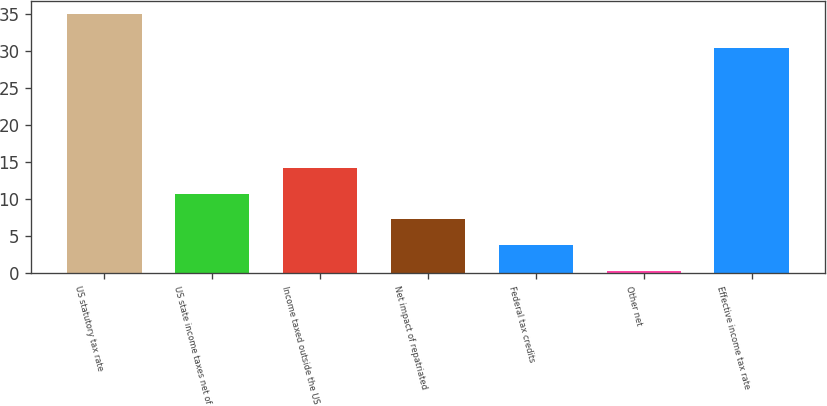<chart> <loc_0><loc_0><loc_500><loc_500><bar_chart><fcel>US statutory tax rate<fcel>US state income taxes net of<fcel>Income taxed outside the US<fcel>Net impact of repatriated<fcel>Federal tax credits<fcel>Other net<fcel>Effective income tax rate<nl><fcel>35<fcel>10.71<fcel>14.18<fcel>7.24<fcel>3.77<fcel>0.3<fcel>30.3<nl></chart> 